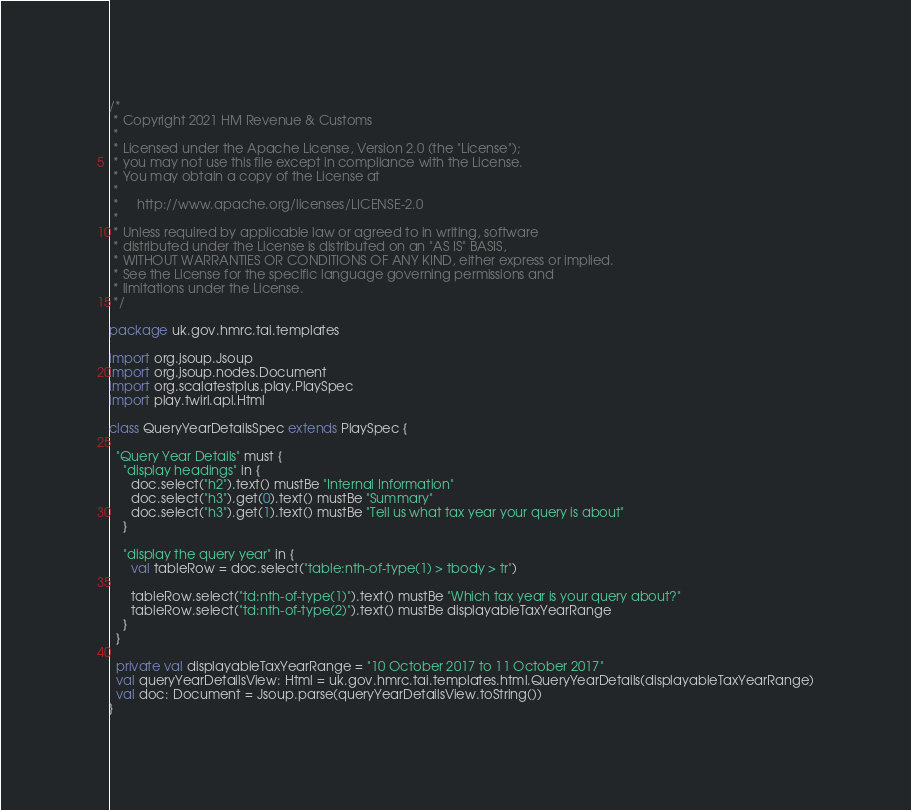<code> <loc_0><loc_0><loc_500><loc_500><_Scala_>/*
 * Copyright 2021 HM Revenue & Customs
 *
 * Licensed under the Apache License, Version 2.0 (the "License");
 * you may not use this file except in compliance with the License.
 * You may obtain a copy of the License at
 *
 *     http://www.apache.org/licenses/LICENSE-2.0
 *
 * Unless required by applicable law or agreed to in writing, software
 * distributed under the License is distributed on an "AS IS" BASIS,
 * WITHOUT WARRANTIES OR CONDITIONS OF ANY KIND, either express or implied.
 * See the License for the specific language governing permissions and
 * limitations under the License.
 */

package uk.gov.hmrc.tai.templates

import org.jsoup.Jsoup
import org.jsoup.nodes.Document
import org.scalatestplus.play.PlaySpec
import play.twirl.api.Html

class QueryYearDetailsSpec extends PlaySpec {

  "Query Year Details" must {
    "display headings" in {
      doc.select("h2").text() mustBe "Internal Information"
      doc.select("h3").get(0).text() mustBe "Summary"
      doc.select("h3").get(1).text() mustBe "Tell us what tax year your query is about"
    }

    "display the query year" in {
      val tableRow = doc.select("table:nth-of-type(1) > tbody > tr")

      tableRow.select("td:nth-of-type(1)").text() mustBe "Which tax year is your query about?"
      tableRow.select("td:nth-of-type(2)").text() mustBe displayableTaxYearRange
    }
  }

  private val displayableTaxYearRange = "10 October 2017 to 11 October 2017"
  val queryYearDetailsView: Html = uk.gov.hmrc.tai.templates.html.QueryYearDetails(displayableTaxYearRange)
  val doc: Document = Jsoup.parse(queryYearDetailsView.toString())
}
</code> 